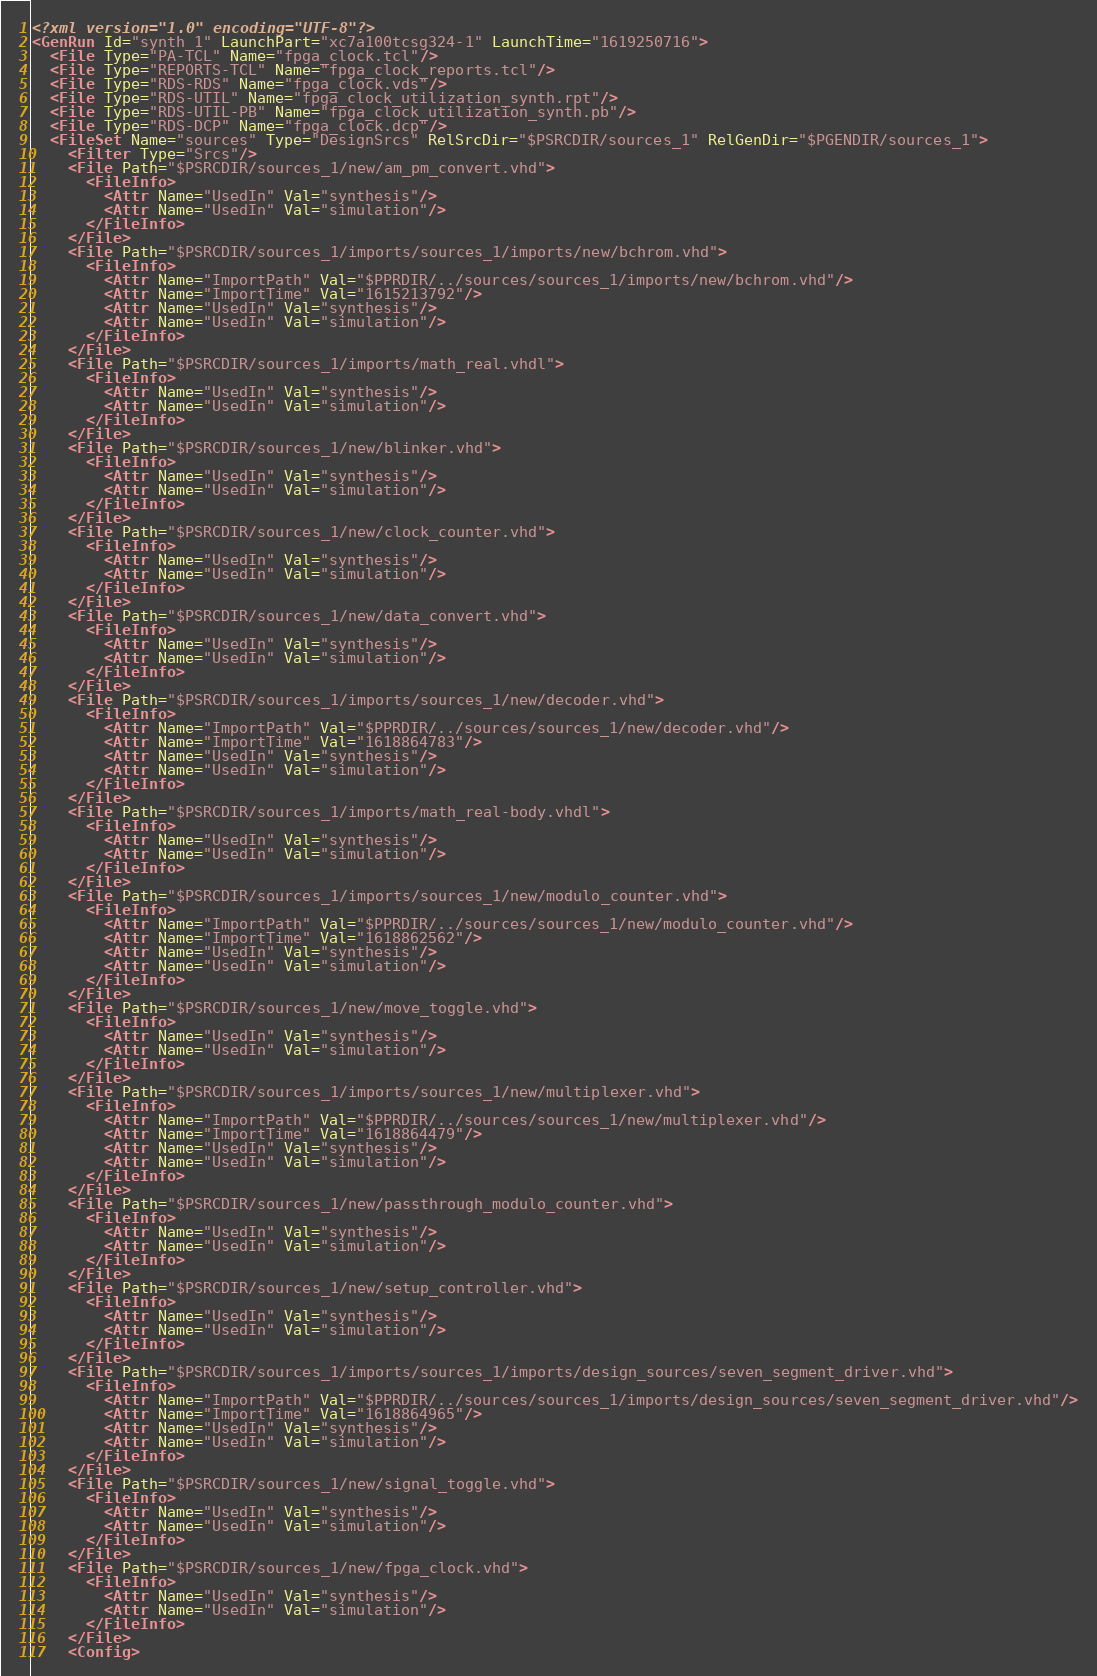<code> <loc_0><loc_0><loc_500><loc_500><_XML_><?xml version="1.0" encoding="UTF-8"?>
<GenRun Id="synth_1" LaunchPart="xc7a100tcsg324-1" LaunchTime="1619250716">
  <File Type="PA-TCL" Name="fpga_clock.tcl"/>
  <File Type="REPORTS-TCL" Name="fpga_clock_reports.tcl"/>
  <File Type="RDS-RDS" Name="fpga_clock.vds"/>
  <File Type="RDS-UTIL" Name="fpga_clock_utilization_synth.rpt"/>
  <File Type="RDS-UTIL-PB" Name="fpga_clock_utilization_synth.pb"/>
  <File Type="RDS-DCP" Name="fpga_clock.dcp"/>
  <FileSet Name="sources" Type="DesignSrcs" RelSrcDir="$PSRCDIR/sources_1" RelGenDir="$PGENDIR/sources_1">
    <Filter Type="Srcs"/>
    <File Path="$PSRCDIR/sources_1/new/am_pm_convert.vhd">
      <FileInfo>
        <Attr Name="UsedIn" Val="synthesis"/>
        <Attr Name="UsedIn" Val="simulation"/>
      </FileInfo>
    </File>
    <File Path="$PSRCDIR/sources_1/imports/sources_1/imports/new/bchrom.vhd">
      <FileInfo>
        <Attr Name="ImportPath" Val="$PPRDIR/../sources/sources_1/imports/new/bchrom.vhd"/>
        <Attr Name="ImportTime" Val="1615213792"/>
        <Attr Name="UsedIn" Val="synthesis"/>
        <Attr Name="UsedIn" Val="simulation"/>
      </FileInfo>
    </File>
    <File Path="$PSRCDIR/sources_1/imports/math_real.vhdl">
      <FileInfo>
        <Attr Name="UsedIn" Val="synthesis"/>
        <Attr Name="UsedIn" Val="simulation"/>
      </FileInfo>
    </File>
    <File Path="$PSRCDIR/sources_1/new/blinker.vhd">
      <FileInfo>
        <Attr Name="UsedIn" Val="synthesis"/>
        <Attr Name="UsedIn" Val="simulation"/>
      </FileInfo>
    </File>
    <File Path="$PSRCDIR/sources_1/new/clock_counter.vhd">
      <FileInfo>
        <Attr Name="UsedIn" Val="synthesis"/>
        <Attr Name="UsedIn" Val="simulation"/>
      </FileInfo>
    </File>
    <File Path="$PSRCDIR/sources_1/new/data_convert.vhd">
      <FileInfo>
        <Attr Name="UsedIn" Val="synthesis"/>
        <Attr Name="UsedIn" Val="simulation"/>
      </FileInfo>
    </File>
    <File Path="$PSRCDIR/sources_1/imports/sources_1/new/decoder.vhd">
      <FileInfo>
        <Attr Name="ImportPath" Val="$PPRDIR/../sources/sources_1/new/decoder.vhd"/>
        <Attr Name="ImportTime" Val="1618864783"/>
        <Attr Name="UsedIn" Val="synthesis"/>
        <Attr Name="UsedIn" Val="simulation"/>
      </FileInfo>
    </File>
    <File Path="$PSRCDIR/sources_1/imports/math_real-body.vhdl">
      <FileInfo>
        <Attr Name="UsedIn" Val="synthesis"/>
        <Attr Name="UsedIn" Val="simulation"/>
      </FileInfo>
    </File>
    <File Path="$PSRCDIR/sources_1/imports/sources_1/new/modulo_counter.vhd">
      <FileInfo>
        <Attr Name="ImportPath" Val="$PPRDIR/../sources/sources_1/new/modulo_counter.vhd"/>
        <Attr Name="ImportTime" Val="1618862562"/>
        <Attr Name="UsedIn" Val="synthesis"/>
        <Attr Name="UsedIn" Val="simulation"/>
      </FileInfo>
    </File>
    <File Path="$PSRCDIR/sources_1/new/move_toggle.vhd">
      <FileInfo>
        <Attr Name="UsedIn" Val="synthesis"/>
        <Attr Name="UsedIn" Val="simulation"/>
      </FileInfo>
    </File>
    <File Path="$PSRCDIR/sources_1/imports/sources_1/new/multiplexer.vhd">
      <FileInfo>
        <Attr Name="ImportPath" Val="$PPRDIR/../sources/sources_1/new/multiplexer.vhd"/>
        <Attr Name="ImportTime" Val="1618864479"/>
        <Attr Name="UsedIn" Val="synthesis"/>
        <Attr Name="UsedIn" Val="simulation"/>
      </FileInfo>
    </File>
    <File Path="$PSRCDIR/sources_1/new/passthrough_modulo_counter.vhd">
      <FileInfo>
        <Attr Name="UsedIn" Val="synthesis"/>
        <Attr Name="UsedIn" Val="simulation"/>
      </FileInfo>
    </File>
    <File Path="$PSRCDIR/sources_1/new/setup_controller.vhd">
      <FileInfo>
        <Attr Name="UsedIn" Val="synthesis"/>
        <Attr Name="UsedIn" Val="simulation"/>
      </FileInfo>
    </File>
    <File Path="$PSRCDIR/sources_1/imports/sources_1/imports/design_sources/seven_segment_driver.vhd">
      <FileInfo>
        <Attr Name="ImportPath" Val="$PPRDIR/../sources/sources_1/imports/design_sources/seven_segment_driver.vhd"/>
        <Attr Name="ImportTime" Val="1618864965"/>
        <Attr Name="UsedIn" Val="synthesis"/>
        <Attr Name="UsedIn" Val="simulation"/>
      </FileInfo>
    </File>
    <File Path="$PSRCDIR/sources_1/new/signal_toggle.vhd">
      <FileInfo>
        <Attr Name="UsedIn" Val="synthesis"/>
        <Attr Name="UsedIn" Val="simulation"/>
      </FileInfo>
    </File>
    <File Path="$PSRCDIR/sources_1/new/fpga_clock.vhd">
      <FileInfo>
        <Attr Name="UsedIn" Val="synthesis"/>
        <Attr Name="UsedIn" Val="simulation"/>
      </FileInfo>
    </File>
    <Config></code> 